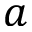Convert formula to latex. <formula><loc_0><loc_0><loc_500><loc_500>a</formula> 